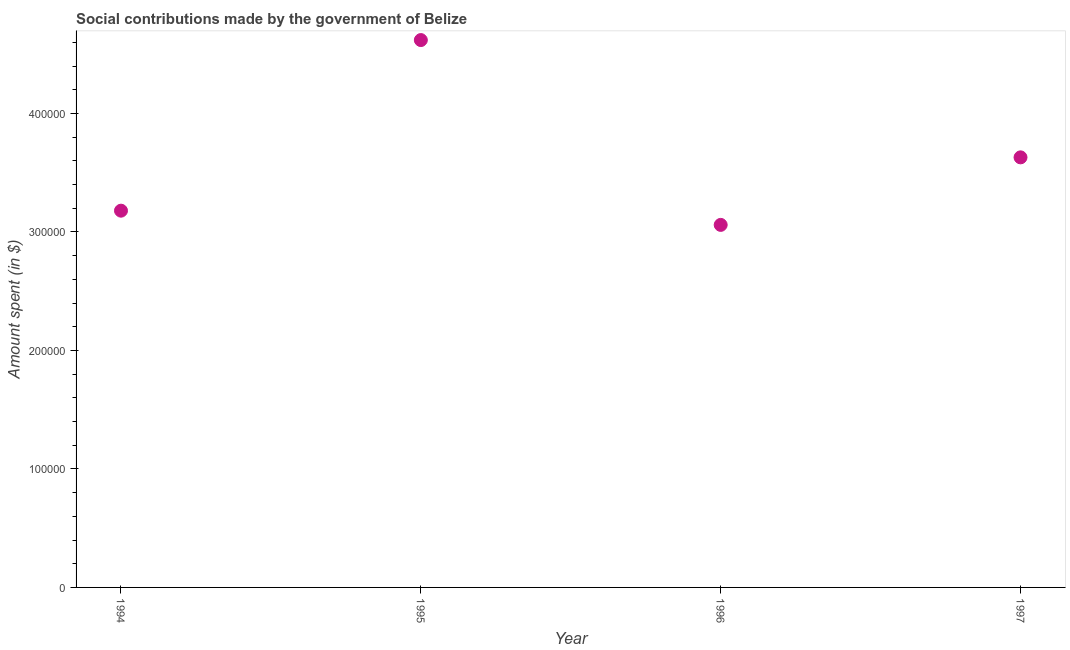What is the amount spent in making social contributions in 1997?
Your answer should be compact. 3.63e+05. Across all years, what is the maximum amount spent in making social contributions?
Your response must be concise. 4.62e+05. Across all years, what is the minimum amount spent in making social contributions?
Your answer should be compact. 3.06e+05. In which year was the amount spent in making social contributions maximum?
Make the answer very short. 1995. In which year was the amount spent in making social contributions minimum?
Your response must be concise. 1996. What is the sum of the amount spent in making social contributions?
Ensure brevity in your answer.  1.45e+06. What is the difference between the amount spent in making social contributions in 1995 and 1997?
Make the answer very short. 9.90e+04. What is the average amount spent in making social contributions per year?
Your answer should be very brief. 3.62e+05. What is the median amount spent in making social contributions?
Offer a terse response. 3.40e+05. In how many years, is the amount spent in making social contributions greater than 300000 $?
Your answer should be compact. 4. What is the ratio of the amount spent in making social contributions in 1994 to that in 1995?
Make the answer very short. 0.69. Is the amount spent in making social contributions in 1994 less than that in 1997?
Give a very brief answer. Yes. Is the difference between the amount spent in making social contributions in 1994 and 1995 greater than the difference between any two years?
Offer a very short reply. No. What is the difference between the highest and the second highest amount spent in making social contributions?
Offer a very short reply. 9.90e+04. Is the sum of the amount spent in making social contributions in 1994 and 1996 greater than the maximum amount spent in making social contributions across all years?
Your response must be concise. Yes. What is the difference between the highest and the lowest amount spent in making social contributions?
Your response must be concise. 1.56e+05. In how many years, is the amount spent in making social contributions greater than the average amount spent in making social contributions taken over all years?
Your answer should be very brief. 2. How many dotlines are there?
Make the answer very short. 1. How many years are there in the graph?
Offer a very short reply. 4. What is the title of the graph?
Provide a succinct answer. Social contributions made by the government of Belize. What is the label or title of the X-axis?
Your response must be concise. Year. What is the label or title of the Y-axis?
Offer a very short reply. Amount spent (in $). What is the Amount spent (in $) in 1994?
Your answer should be very brief. 3.18e+05. What is the Amount spent (in $) in 1995?
Offer a very short reply. 4.62e+05. What is the Amount spent (in $) in 1996?
Give a very brief answer. 3.06e+05. What is the Amount spent (in $) in 1997?
Provide a succinct answer. 3.63e+05. What is the difference between the Amount spent (in $) in 1994 and 1995?
Your answer should be very brief. -1.44e+05. What is the difference between the Amount spent (in $) in 1994 and 1996?
Ensure brevity in your answer.  1.20e+04. What is the difference between the Amount spent (in $) in 1994 and 1997?
Your response must be concise. -4.50e+04. What is the difference between the Amount spent (in $) in 1995 and 1996?
Your answer should be compact. 1.56e+05. What is the difference between the Amount spent (in $) in 1995 and 1997?
Your response must be concise. 9.90e+04. What is the difference between the Amount spent (in $) in 1996 and 1997?
Keep it short and to the point. -5.70e+04. What is the ratio of the Amount spent (in $) in 1994 to that in 1995?
Provide a short and direct response. 0.69. What is the ratio of the Amount spent (in $) in 1994 to that in 1996?
Offer a very short reply. 1.04. What is the ratio of the Amount spent (in $) in 1994 to that in 1997?
Offer a terse response. 0.88. What is the ratio of the Amount spent (in $) in 1995 to that in 1996?
Offer a very short reply. 1.51. What is the ratio of the Amount spent (in $) in 1995 to that in 1997?
Offer a terse response. 1.27. What is the ratio of the Amount spent (in $) in 1996 to that in 1997?
Your answer should be compact. 0.84. 